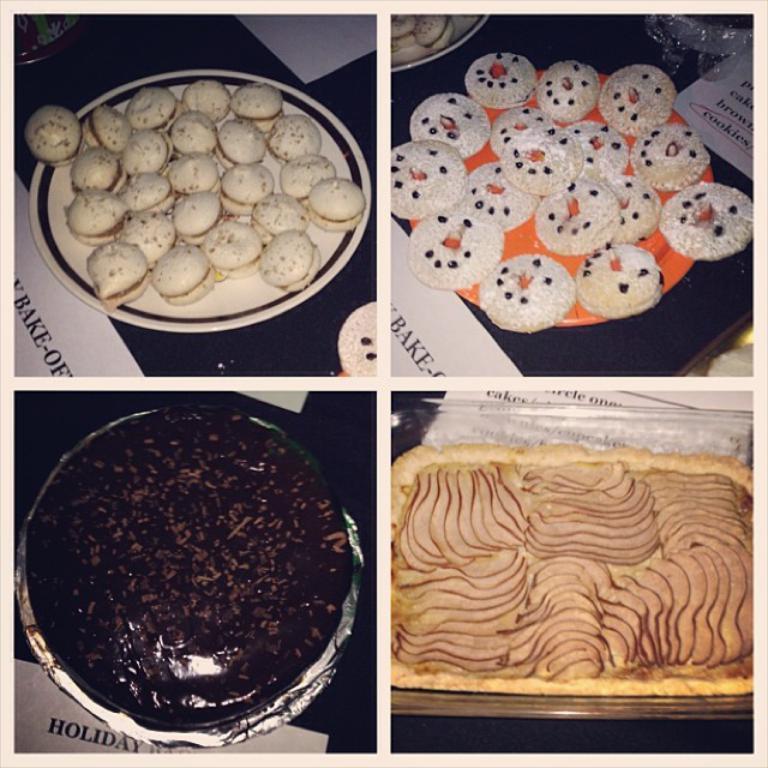Please provide a concise description of this image. This is a collage edited image and there are four images in it. In all the images we can see food items in the plates on platforms and there are papers also on the platforms. 